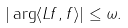<formula> <loc_0><loc_0><loc_500><loc_500>| \arg \langle L f , f \rangle | \leq \omega .</formula> 